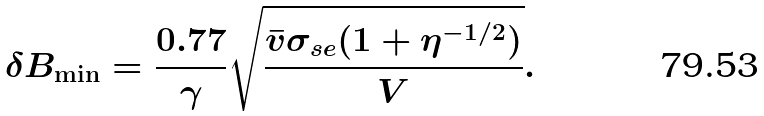Convert formula to latex. <formula><loc_0><loc_0><loc_500><loc_500>\delta B _ { \min } = \frac { 0 . 7 7 } { \gamma } \sqrt { \frac { \bar { v } \sigma _ { s e } ( 1 + \eta ^ { - 1 / 2 } ) } { V } } .</formula> 